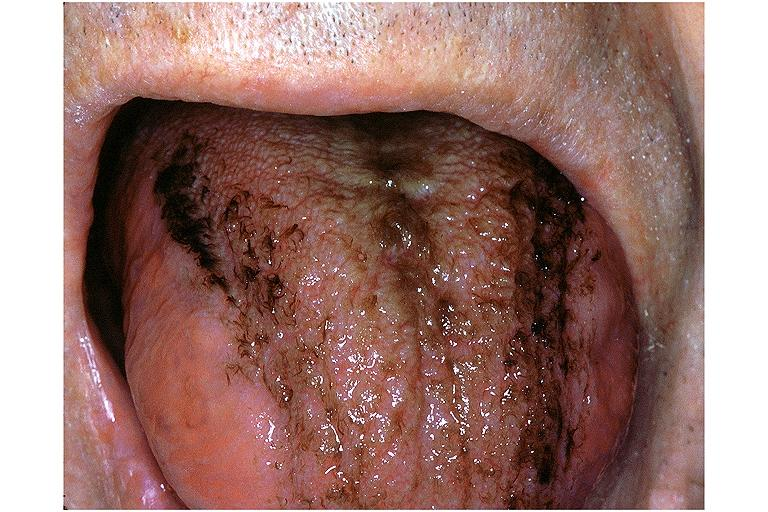s oral present?
Answer the question using a single word or phrase. Yes 